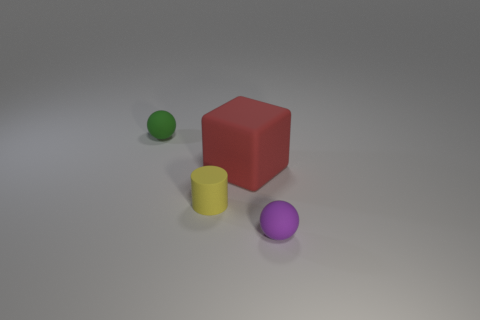What number of yellow matte cylinders are the same size as the matte cube?
Give a very brief answer. 0. There is a tiny rubber sphere on the left side of the small purple rubber thing; is its color the same as the matte cylinder?
Ensure brevity in your answer.  No. There is a tiny thing that is both on the left side of the large red matte object and in front of the green rubber thing; what is its material?
Offer a terse response. Rubber. Are there more tiny gray metal things than large red things?
Your answer should be very brief. No. There is a tiny sphere in front of the ball behind the rubber ball that is right of the tiny green sphere; what is its color?
Provide a short and direct response. Purple. Does the tiny thing that is right of the large cube have the same material as the small yellow cylinder?
Keep it short and to the point. Yes. Are there any other tiny cylinders of the same color as the tiny cylinder?
Keep it short and to the point. No. Are there any rubber cylinders?
Make the answer very short. Yes. Do the matte ball in front of the yellow rubber cylinder and the green rubber object have the same size?
Give a very brief answer. Yes. Is the number of big blue spheres less than the number of green objects?
Provide a succinct answer. Yes. 